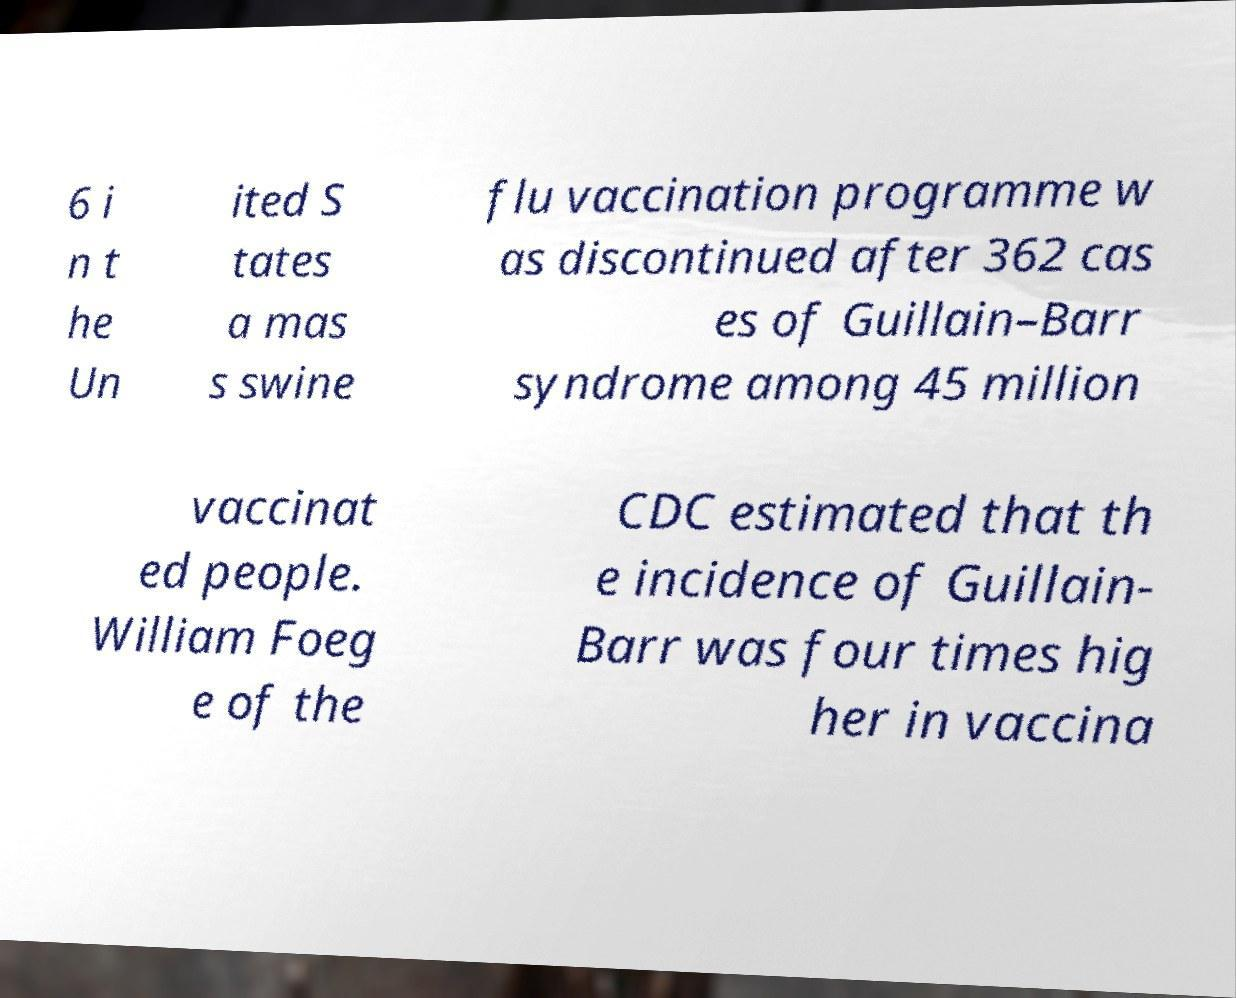I need the written content from this picture converted into text. Can you do that? 6 i n t he Un ited S tates a mas s swine flu vaccination programme w as discontinued after 362 cas es of Guillain–Barr syndrome among 45 million vaccinat ed people. William Foeg e of the CDC estimated that th e incidence of Guillain- Barr was four times hig her in vaccina 